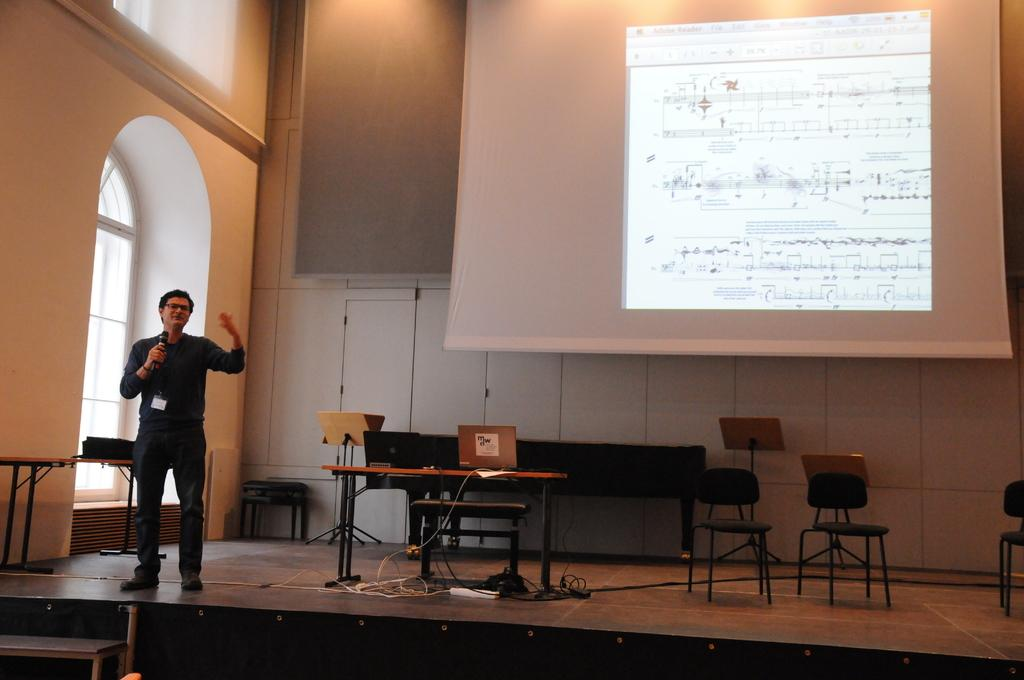What is the person in the image doing? The person is standing and holding a microphone. What objects can be seen in the image besides the person? There is a door, a table, a chair, and a screen visible in the image. Are there any cables present in the image? Yes, there are cables visible in the image. What type of dinosaurs can be seen in the image? There are no dinosaurs present in the image. How does the person's temper affect the screen in the background? The person's temper is not mentioned in the image, and therefore its effect on the screen cannot be determined. 